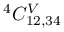<formula> <loc_0><loc_0><loc_500><loc_500>^ { 4 } C _ { 1 2 , 3 4 } ^ { V }</formula> 